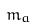Convert formula to latex. <formula><loc_0><loc_0><loc_500><loc_500>m _ { a }</formula> 